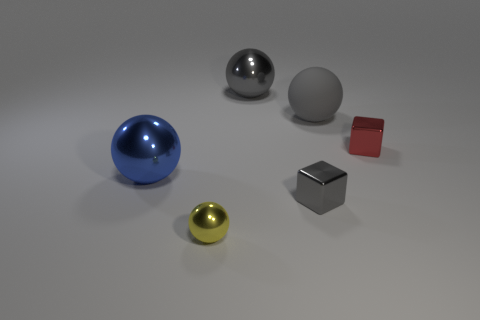Is there any other thing that is the same color as the big rubber sphere?
Your response must be concise. Yes. There is a small yellow object that is made of the same material as the blue sphere; what shape is it?
Offer a terse response. Sphere. Does the gray metal sphere have the same size as the blue sphere?
Your answer should be compact. Yes. Do the gray sphere in front of the large gray metal object and the tiny ball have the same material?
Ensure brevity in your answer.  No. There is a big ball that is right of the large gray thing behind the big gray matte thing; how many tiny objects are to the right of it?
Give a very brief answer. 1. Does the large gray object on the right side of the big gray metallic object have the same shape as the red thing?
Provide a short and direct response. No. What number of things are big red objects or large balls in front of the large gray metallic thing?
Keep it short and to the point. 2. Is the number of large gray balls that are behind the gray block greater than the number of metal cylinders?
Give a very brief answer. Yes. Are there an equal number of small things in front of the big blue object and gray rubber balls that are behind the big gray metallic sphere?
Give a very brief answer. No. There is a big metallic thing that is behind the blue sphere; is there a tiny gray metal cube right of it?
Ensure brevity in your answer.  Yes. 